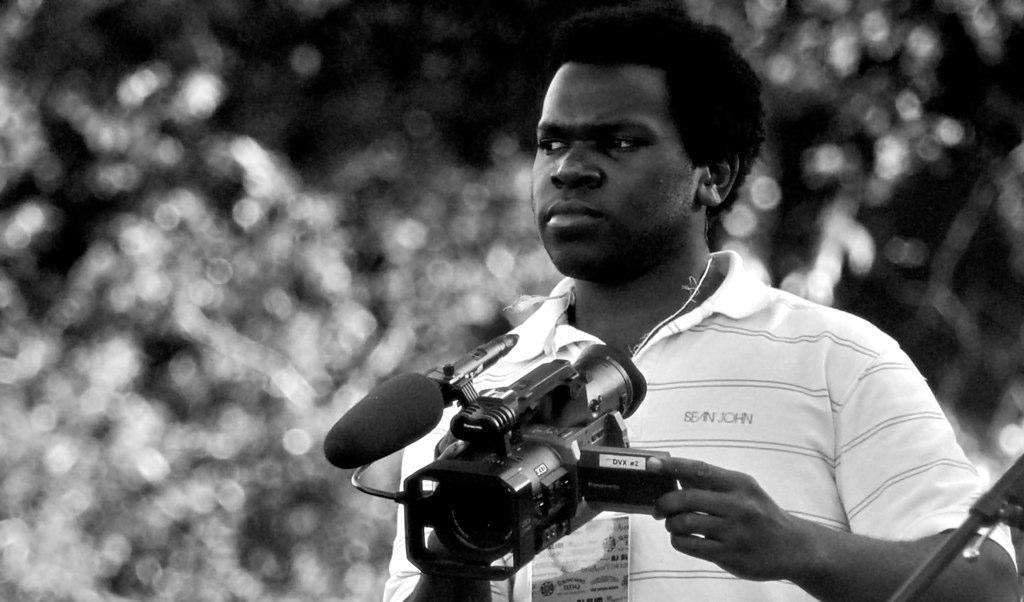What is the main subject of the image? The main subject of the image is a man. What is the man holding in the image? The man is holding a camera with his hands. What type of bells can be heard ringing in the image? There are no bells or sounds present in the image, as it is a still photograph of a man holding a camera. 